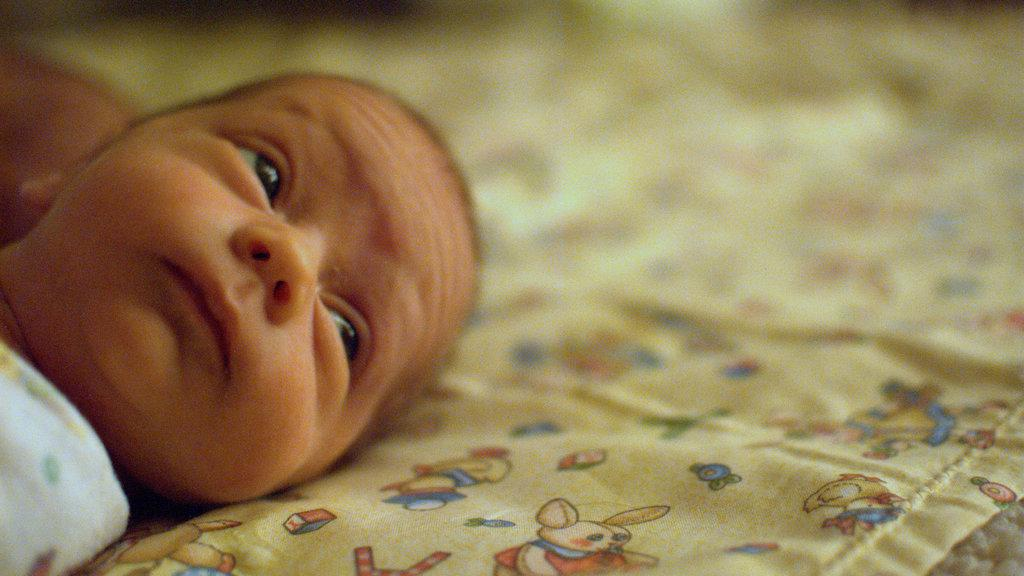What is the main subject of the image? The main subject of the image is a baby. What is the baby wearing in the image? The baby is wearing a white dress in the image. What is the baby laying on in the image? The baby is laying on a cream-colored surface in the image. What type of flag is visible in the image? There is no flag present in the image. What kind of structure can be seen in the background of the image? There is no structure visible in the image; it only shows the baby laying on a cream-colored surface. Is the baby's grandfather present in the image? There is no indication of the baby's grandfather or any other person in the image. 